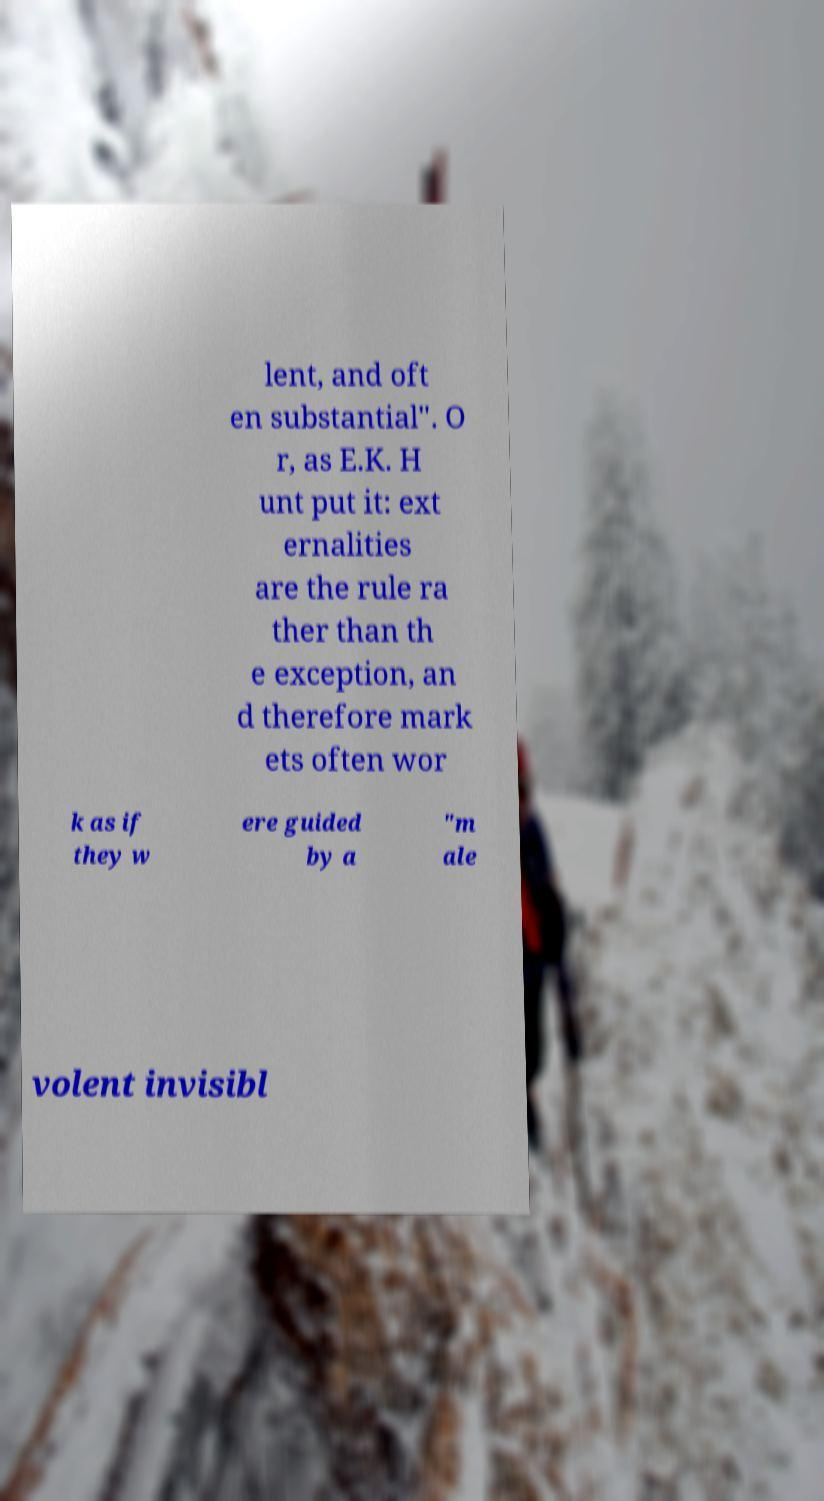Please identify and transcribe the text found in this image. lent, and oft en substantial". O r, as E.K. H unt put it: ext ernalities are the rule ra ther than th e exception, an d therefore mark ets often wor k as if they w ere guided by a "m ale volent invisibl 